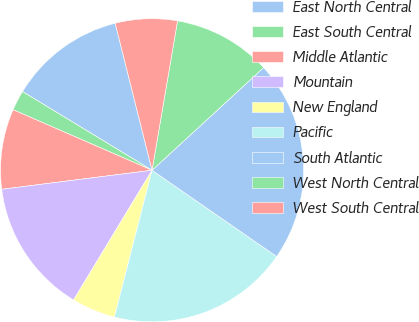<chart> <loc_0><loc_0><loc_500><loc_500><pie_chart><fcel>East North Central<fcel>East South Central<fcel>Middle Atlantic<fcel>Mountain<fcel>New England<fcel>Pacific<fcel>South Atlantic<fcel>West North Central<fcel>West South Central<nl><fcel>12.4%<fcel>2.15%<fcel>8.54%<fcel>14.33%<fcel>4.67%<fcel>19.35%<fcel>21.47%<fcel>10.47%<fcel>6.6%<nl></chart> 